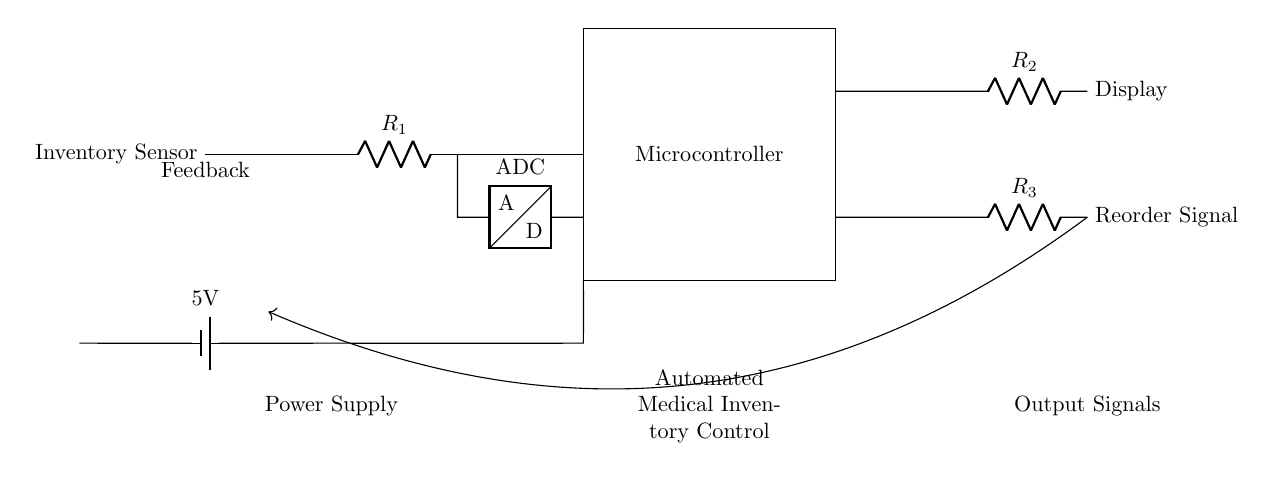What is the main component in this circuit? The main component is the microcontroller, which controls the automated inventory system. It's the largest part of the circuit and serves as the central processing unit for data handling.
Answer: microcontroller What type of signal is produced by the Reorder Signal component? The Reorder Signal represents a notification or alert to indicate that inventory levels should be replenished. It's generated based on the data processed by the microcontroller and the feedback from the inventory levels.
Answer: alert What is the purpose of the Inventory Sensor? The Inventory Sensor's purpose is to monitor the levels of medical inventory in real-time, providing data to the microcontroller for decision making.
Answer: monitor inventory How many resistors are present in this circuit? The circuit contains three resistors that are marked as R1, R2, and R3. Each resistor serves a different function in regulating the flow of current in the circuit.
Answer: three What role does the ADC play in this circuit? The ADC converts the analog signals generated by the Inventory Sensor into digital signals that the microcontroller can process. This is vital for data analysis and decision-making regarding inventory levels.
Answer: conversion What is the voltage provided by the power supply? The power supply provides a voltage of five volts, which is sufficient for powering the microcontroller and other components within the circuit.
Answer: five volts What does the feedback loop indicate in this control circuit? The feedback loop indicates a closed-loop control system, allowing the circuit to adjust its operations based on the performance of current inventory status, optimizing the stock levels to reduce waste.
Answer: optimization 